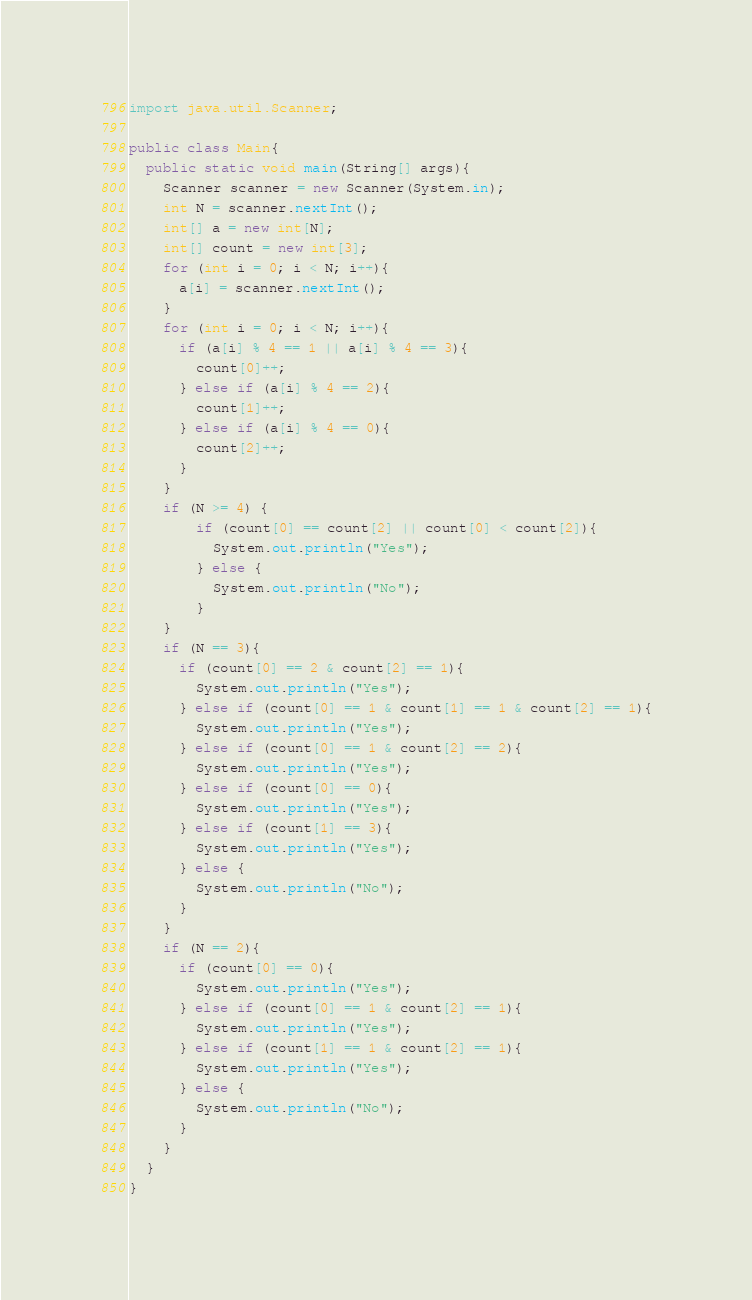<code> <loc_0><loc_0><loc_500><loc_500><_Java_>import java.util.Scanner;

public class Main{
  public static void main(String[] args){
    Scanner scanner = new Scanner(System.in);
    int N = scanner.nextInt();
    int[] a = new int[N];
    int[] count = new int[3];
    for (int i = 0; i < N; i++){
      a[i] = scanner.nextInt();
    }
    for (int i = 0; i < N; i++){
      if (a[i] % 4 == 1 || a[i] % 4 == 3){
        count[0]++;
      } else if (a[i] % 4 == 2){
        count[1]++;
      } else if (a[i] % 4 == 0){
        count[2]++;
      }
    }
    if (N >= 4) {
        if (count[0] == count[2] || count[0] < count[2]){
          System.out.println("Yes");
        } else {
          System.out.println("No");
        }
    }
    if (N == 3){
      if (count[0] == 2 & count[2] == 1){
        System.out.println("Yes");
      } else if (count[0] == 1 & count[1] == 1 & count[2] == 1){
        System.out.println("Yes");
      } else if (count[0] == 1 & count[2] == 2){
        System.out.println("Yes");
      } else if (count[0] == 0){
        System.out.println("Yes");
      } else if (count[1] == 3){
        System.out.println("Yes");
      } else {
        System.out.println("No");
      }
    }
    if (N == 2){
      if (count[0] == 0){
        System.out.println("Yes");
      } else if (count[0] == 1 & count[2] == 1){
        System.out.println("Yes");
      } else if (count[1] == 1 & count[2] == 1){
        System.out.println("Yes");
      } else {
        System.out.println("No");
      }
    }
  }
}
</code> 